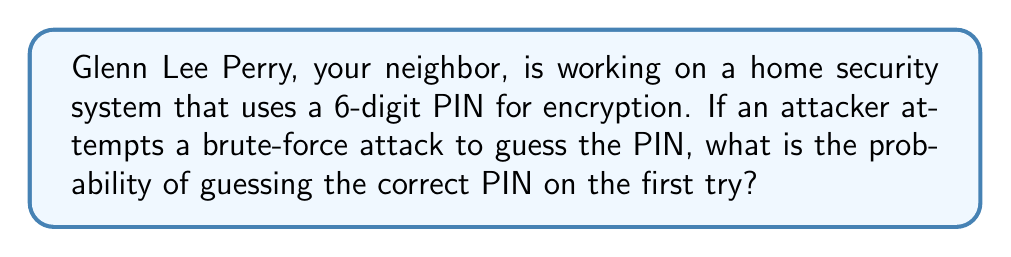Show me your answer to this math problem. To solve this problem, we need to follow these steps:

1. Determine the total number of possible 6-digit PINs:
   - Each digit can be any number from 0 to 9
   - There are 10 choices for each of the 6 positions
   - Total number of possible PINs = $10^6 = 1,000,000$

2. Calculate the probability of guessing the correct PIN on the first try:
   - There is only one correct PIN out of 1,000,000 possibilities
   - Probability = $\frac{\text{Number of favorable outcomes}}{\text{Total number of possible outcomes}}$
   - Probability = $\frac{1}{1,000,000} = 10^{-6}$

Therefore, the probability of guessing the correct 6-digit PIN on the first try in a brute-force attack is $\frac{1}{1,000,000}$ or $10^{-6}$.
Answer: $10^{-6}$ 